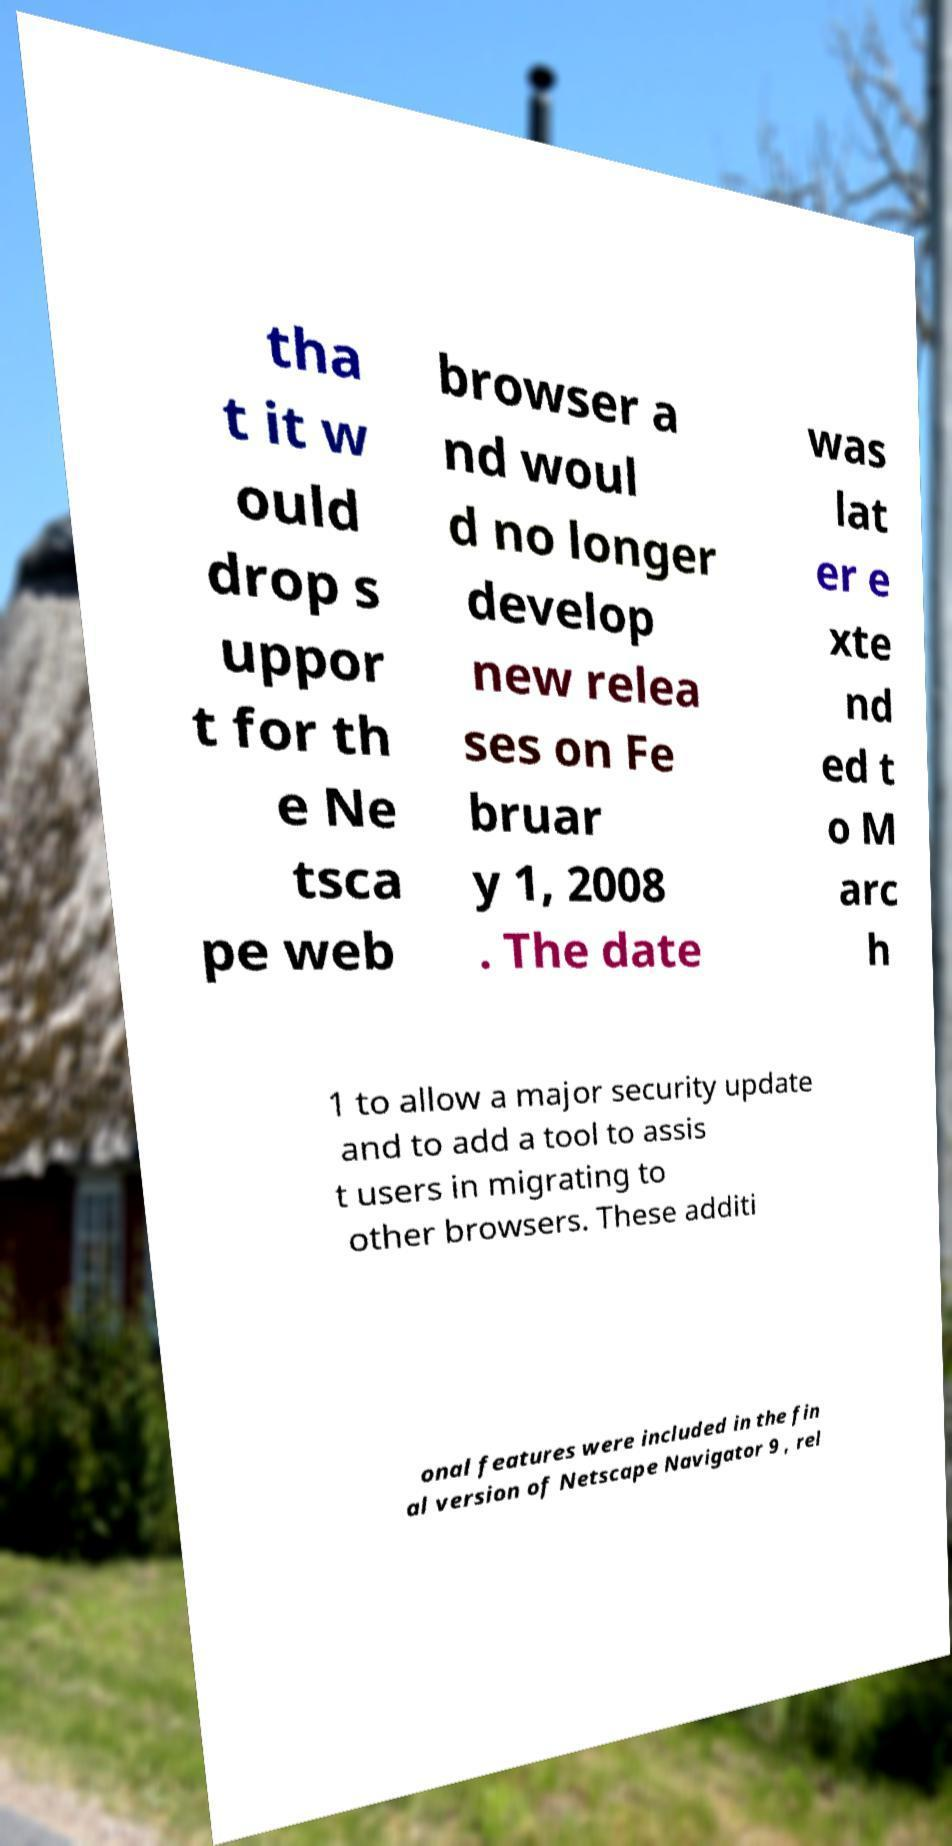What messages or text are displayed in this image? I need them in a readable, typed format. tha t it w ould drop s uppor t for th e Ne tsca pe web browser a nd woul d no longer develop new relea ses on Fe bruar y 1, 2008 . The date was lat er e xte nd ed t o M arc h 1 to allow a major security update and to add a tool to assis t users in migrating to other browsers. These additi onal features were included in the fin al version of Netscape Navigator 9 , rel 